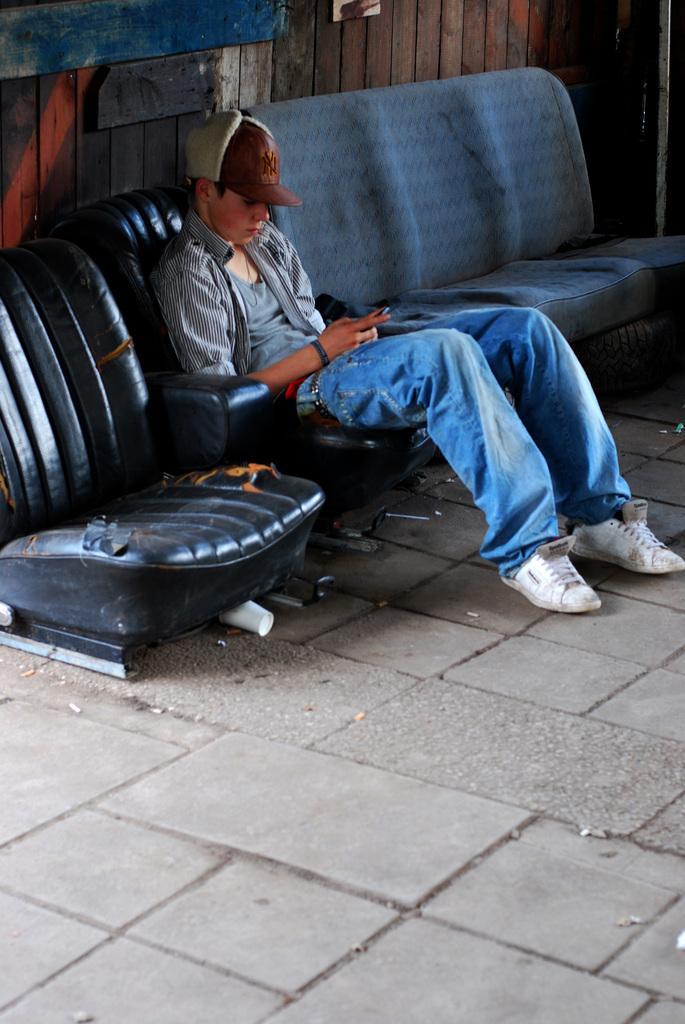Can you describe this image briefly? In this image a boy sitting on chair, beside him there is a sofa, in the background there is a wooden wall. 